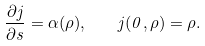<formula> <loc_0><loc_0><loc_500><loc_500>\frac { \partial j } { \partial s } = \alpha ( \rho ) , \quad j ( 0 , \rho ) = \rho .</formula> 